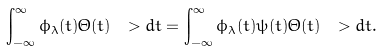Convert formula to latex. <formula><loc_0><loc_0><loc_500><loc_500>\int _ { - \infty } ^ { \infty } \phi _ { \lambda } ( t ) \Theta ( t ) \ > d t = \int _ { - \infty } ^ { \infty } \phi _ { \lambda } ( t ) \psi ( t ) \Theta ( t ) \ > d t .</formula> 